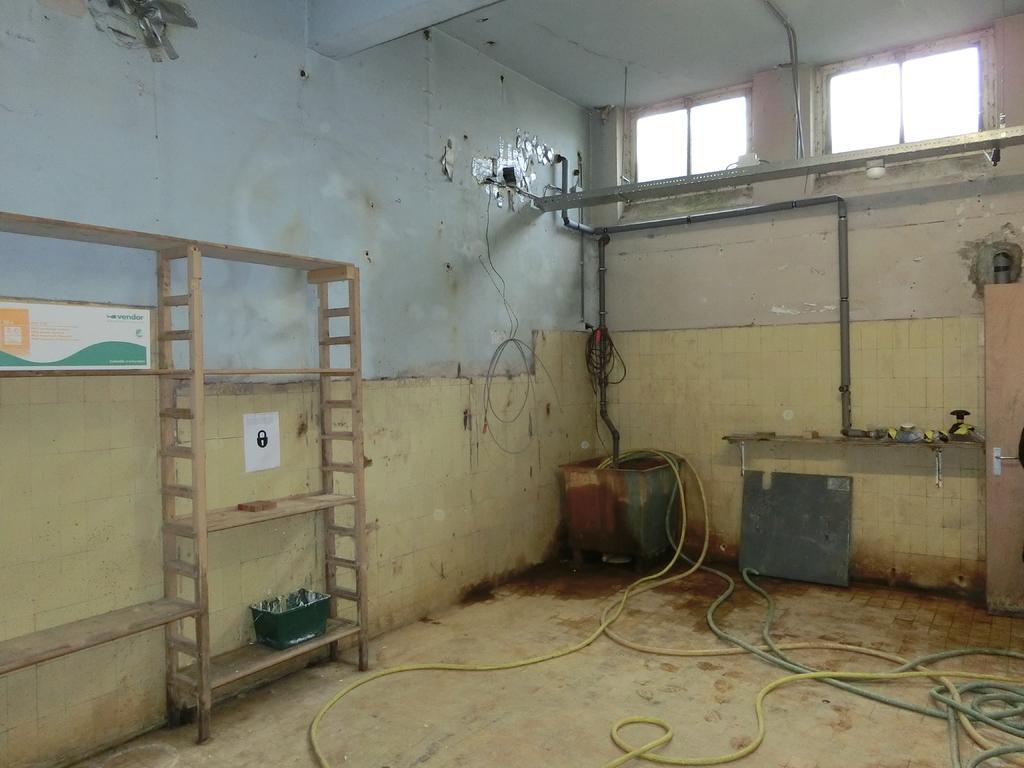Can you describe this image briefly? In this image I can see the room with rack and the box. I can see some pipes in the box. There is a green color basket on the rack. In the back there are pipes to the wall and also the windows to the right. 